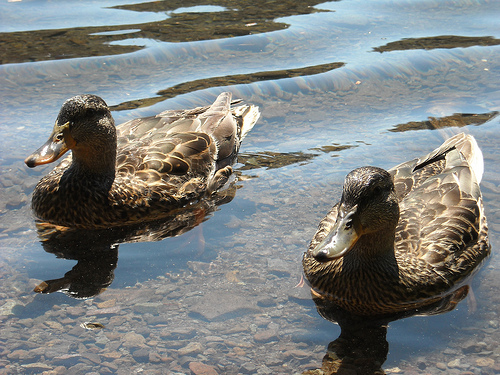<image>
Is the duck in the water? Yes. The duck is contained within or inside the water, showing a containment relationship. Where is the duck in relation to the beak? Is it to the left of the beak? No. The duck is not to the left of the beak. From this viewpoint, they have a different horizontal relationship. 